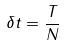Convert formula to latex. <formula><loc_0><loc_0><loc_500><loc_500>\delta t = \frac { T } { N }</formula> 